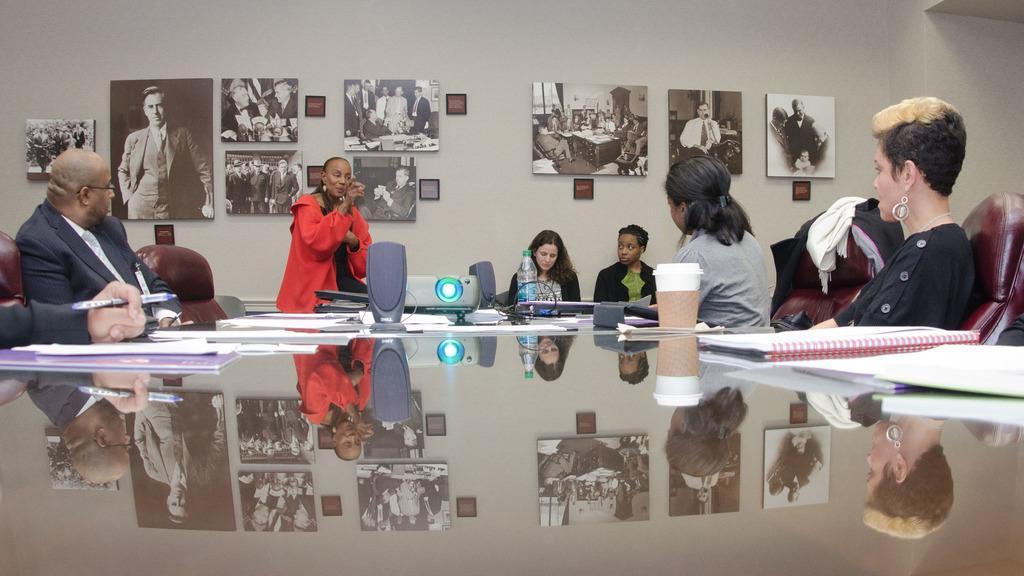How would you summarize this image in a sentence or two? Here we can see a group of people sitting on chairs and a table in front of them with books and papers there is a speaker and a projector on the table and there is a lady standing in the middle speaking something to the people and behind her there is wall full of photo frames 